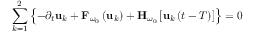<formula> <loc_0><loc_0><loc_500><loc_500>\sum _ { k = 1 } ^ { 2 } \left \{ - \partial _ { t } u _ { k } + { F } _ { \omega _ { 0 } } \left ( { u } _ { k } \right ) + { H } _ { \omega _ { 0 } } \left [ { u } _ { k } \left ( t - T \right ) \right ] \right \} = 0</formula> 